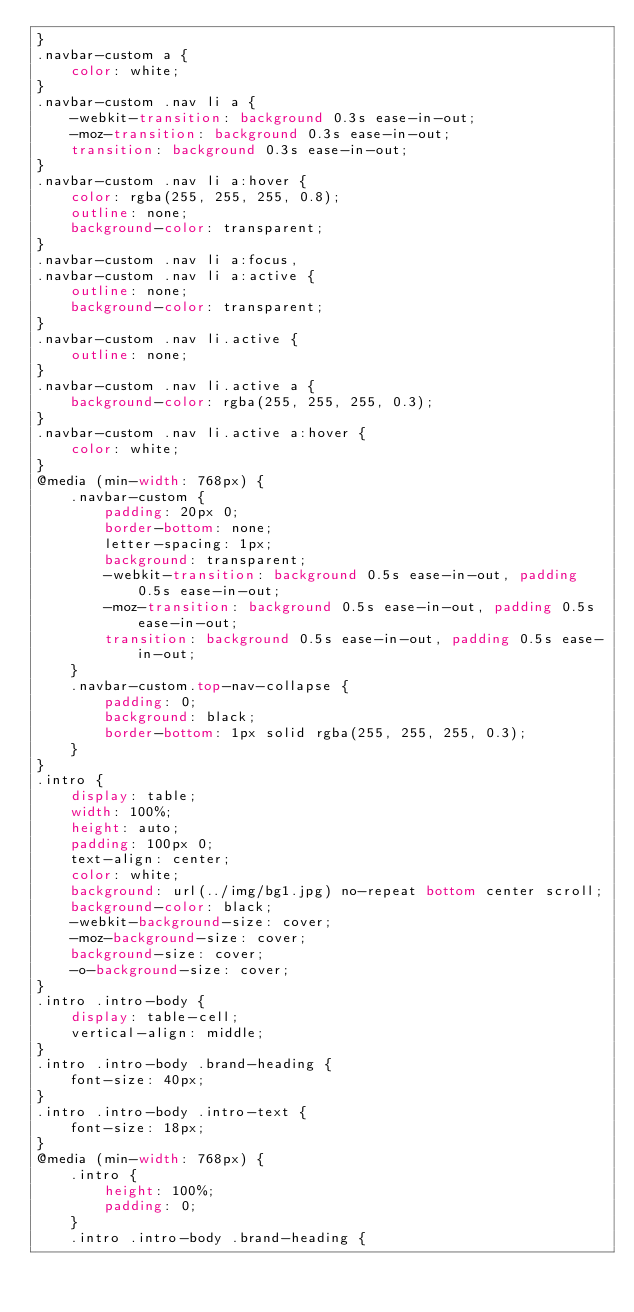<code> <loc_0><loc_0><loc_500><loc_500><_CSS_>}
.navbar-custom a {
    color: white;
}
.navbar-custom .nav li a {
    -webkit-transition: background 0.3s ease-in-out;
    -moz-transition: background 0.3s ease-in-out;
    transition: background 0.3s ease-in-out;
}
.navbar-custom .nav li a:hover {
    color: rgba(255, 255, 255, 0.8);
    outline: none;
    background-color: transparent;
}
.navbar-custom .nav li a:focus,
.navbar-custom .nav li a:active {
    outline: none;
    background-color: transparent;
}
.navbar-custom .nav li.active {
    outline: none;
}
.navbar-custom .nav li.active a {
    background-color: rgba(255, 255, 255, 0.3);
}
.navbar-custom .nav li.active a:hover {
    color: white;
}
@media (min-width: 768px) {
    .navbar-custom {
        padding: 20px 0;
        border-bottom: none;
        letter-spacing: 1px;
        background: transparent;
        -webkit-transition: background 0.5s ease-in-out, padding 0.5s ease-in-out;
        -moz-transition: background 0.5s ease-in-out, padding 0.5s ease-in-out;
        transition: background 0.5s ease-in-out, padding 0.5s ease-in-out;
    }
    .navbar-custom.top-nav-collapse {
        padding: 0;
        background: black;
        border-bottom: 1px solid rgba(255, 255, 255, 0.3);
    }
}
.intro {
    display: table;
    width: 100%;
    height: auto;
    padding: 100px 0;
    text-align: center;
    color: white;
    background: url(../img/bg1.jpg) no-repeat bottom center scroll;
    background-color: black;
    -webkit-background-size: cover;
    -moz-background-size: cover;
    background-size: cover;
    -o-background-size: cover;
}
.intro .intro-body {
    display: table-cell;
    vertical-align: middle;
}
.intro .intro-body .brand-heading {
    font-size: 40px;
}
.intro .intro-body .intro-text {
    font-size: 18px;
}
@media (min-width: 768px) {
    .intro {
        height: 100%;
        padding: 0;
    }
    .intro .intro-body .brand-heading {</code> 